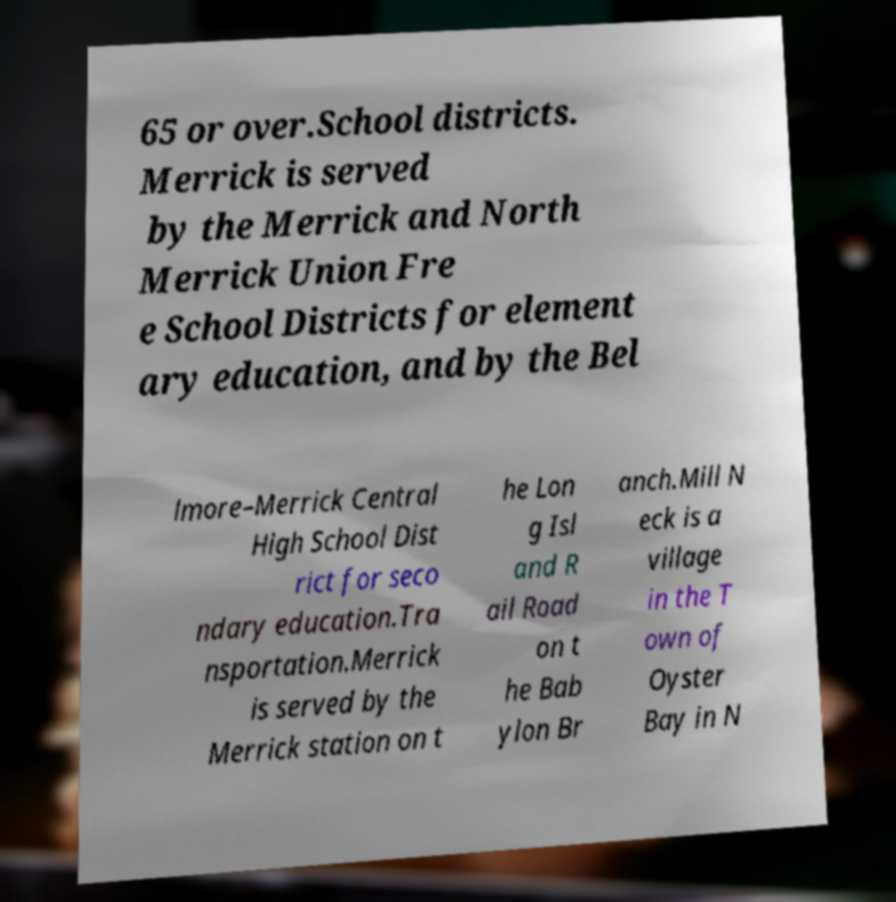What messages or text are displayed in this image? I need them in a readable, typed format. 65 or over.School districts. Merrick is served by the Merrick and North Merrick Union Fre e School Districts for element ary education, and by the Bel lmore–Merrick Central High School Dist rict for seco ndary education.Tra nsportation.Merrick is served by the Merrick station on t he Lon g Isl and R ail Road on t he Bab ylon Br anch.Mill N eck is a village in the T own of Oyster Bay in N 